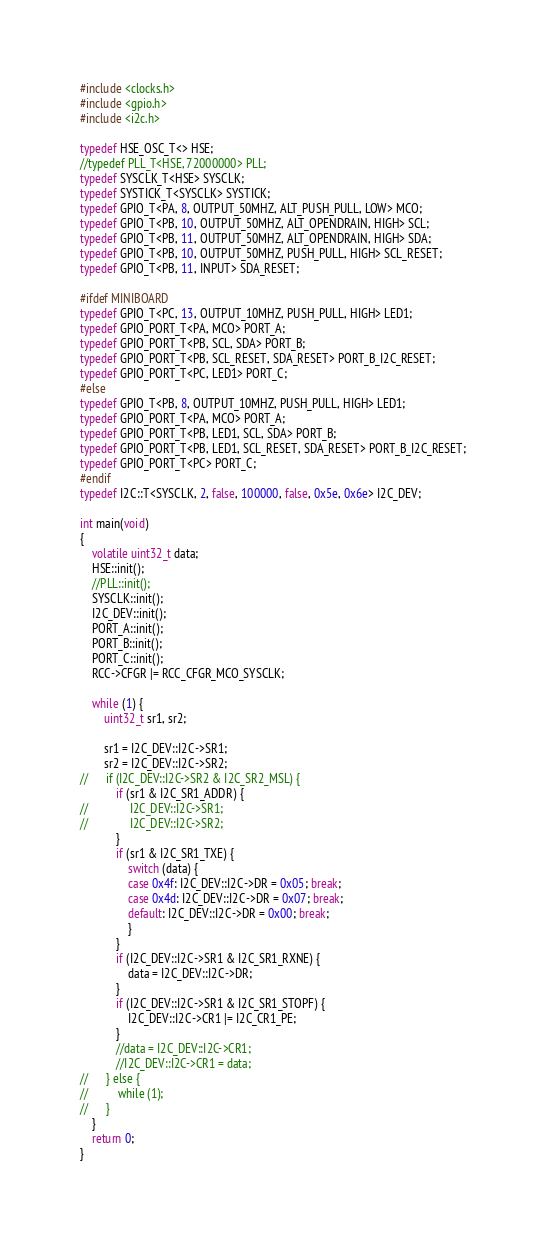<code> <loc_0><loc_0><loc_500><loc_500><_C++_>#include <clocks.h>
#include <gpio.h>
#include <i2c.h>

typedef HSE_OSC_T<> HSE;
//typedef PLL_T<HSE, 72000000> PLL;
typedef SYSCLK_T<HSE> SYSCLK;
typedef SYSTICK_T<SYSCLK> SYSTICK;
typedef GPIO_T<PA, 8, OUTPUT_50MHZ, ALT_PUSH_PULL, LOW> MCO;
typedef GPIO_T<PB, 10, OUTPUT_50MHZ, ALT_OPENDRAIN, HIGH> SCL;
typedef GPIO_T<PB, 11, OUTPUT_50MHZ, ALT_OPENDRAIN, HIGH> SDA;
typedef GPIO_T<PB, 10, OUTPUT_50MHZ, PUSH_PULL, HIGH> SCL_RESET;
typedef GPIO_T<PB, 11, INPUT> SDA_RESET;

#ifdef MINIBOARD
typedef GPIO_T<PC, 13, OUTPUT_10MHZ, PUSH_PULL, HIGH> LED1;
typedef GPIO_PORT_T<PA, MCO> PORT_A;
typedef GPIO_PORT_T<PB, SCL, SDA> PORT_B;
typedef GPIO_PORT_T<PB, SCL_RESET, SDA_RESET> PORT_B_I2C_RESET;
typedef GPIO_PORT_T<PC, LED1> PORT_C;
#else
typedef GPIO_T<PB, 8, OUTPUT_10MHZ, PUSH_PULL, HIGH> LED1;
typedef GPIO_PORT_T<PA, MCO> PORT_A;
typedef GPIO_PORT_T<PB, LED1, SCL, SDA> PORT_B;
typedef GPIO_PORT_T<PB, LED1, SCL_RESET, SDA_RESET> PORT_B_I2C_RESET;
typedef GPIO_PORT_T<PC> PORT_C;
#endif
typedef I2C::T<SYSCLK, 2, false, 100000, false, 0x5e, 0x6e> I2C_DEV;

int main(void)
{
	volatile uint32_t data;
	HSE::init();
	//PLL::init();
	SYSCLK::init();
	I2C_DEV::init();
	PORT_A::init();
	PORT_B::init();
	PORT_C::init();
	RCC->CFGR |= RCC_CFGR_MCO_SYSCLK;

	while (1) {
		uint32_t sr1, sr2;

		sr1 = I2C_DEV::I2C->SR1;
		sr2 = I2C_DEV::I2C->SR2;
//		if (I2C_DEV::I2C->SR2 & I2C_SR2_MSL) {
			if (sr1 & I2C_SR1_ADDR) {
//				I2C_DEV::I2C->SR1;
//				I2C_DEV::I2C->SR2;
			}
			if (sr1 & I2C_SR1_TXE) {
				switch (data) {
				case 0x4f: I2C_DEV::I2C->DR = 0x05; break;
				case 0x4d: I2C_DEV::I2C->DR = 0x07; break;
				default: I2C_DEV::I2C->DR = 0x00; break;
				}
			}
			if (I2C_DEV::I2C->SR1 & I2C_SR1_RXNE) {
				data = I2C_DEV::I2C->DR;
			}
			if (I2C_DEV::I2C->SR1 & I2C_SR1_STOPF) {
				I2C_DEV::I2C->CR1 |= I2C_CR1_PE;
			}
			//data = I2C_DEV::I2C->CR1;
			//I2C_DEV::I2C->CR1 = data;
//		} else {
//			while (1);
//		}
	}
	return 0;
}
</code> 